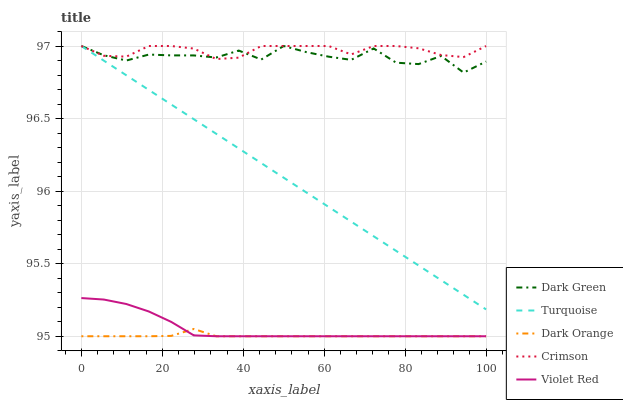Does Dark Orange have the minimum area under the curve?
Answer yes or no. Yes. Does Crimson have the maximum area under the curve?
Answer yes or no. Yes. Does Turquoise have the minimum area under the curve?
Answer yes or no. No. Does Turquoise have the maximum area under the curve?
Answer yes or no. No. Is Turquoise the smoothest?
Answer yes or no. Yes. Is Dark Green the roughest?
Answer yes or no. Yes. Is Dark Orange the smoothest?
Answer yes or no. No. Is Dark Orange the roughest?
Answer yes or no. No. Does Dark Orange have the lowest value?
Answer yes or no. Yes. Does Turquoise have the lowest value?
Answer yes or no. No. Does Dark Green have the highest value?
Answer yes or no. Yes. Does Dark Orange have the highest value?
Answer yes or no. No. Is Dark Orange less than Dark Green?
Answer yes or no. Yes. Is Dark Green greater than Violet Red?
Answer yes or no. Yes. Does Dark Green intersect Crimson?
Answer yes or no. Yes. Is Dark Green less than Crimson?
Answer yes or no. No. Is Dark Green greater than Crimson?
Answer yes or no. No. Does Dark Orange intersect Dark Green?
Answer yes or no. No. 